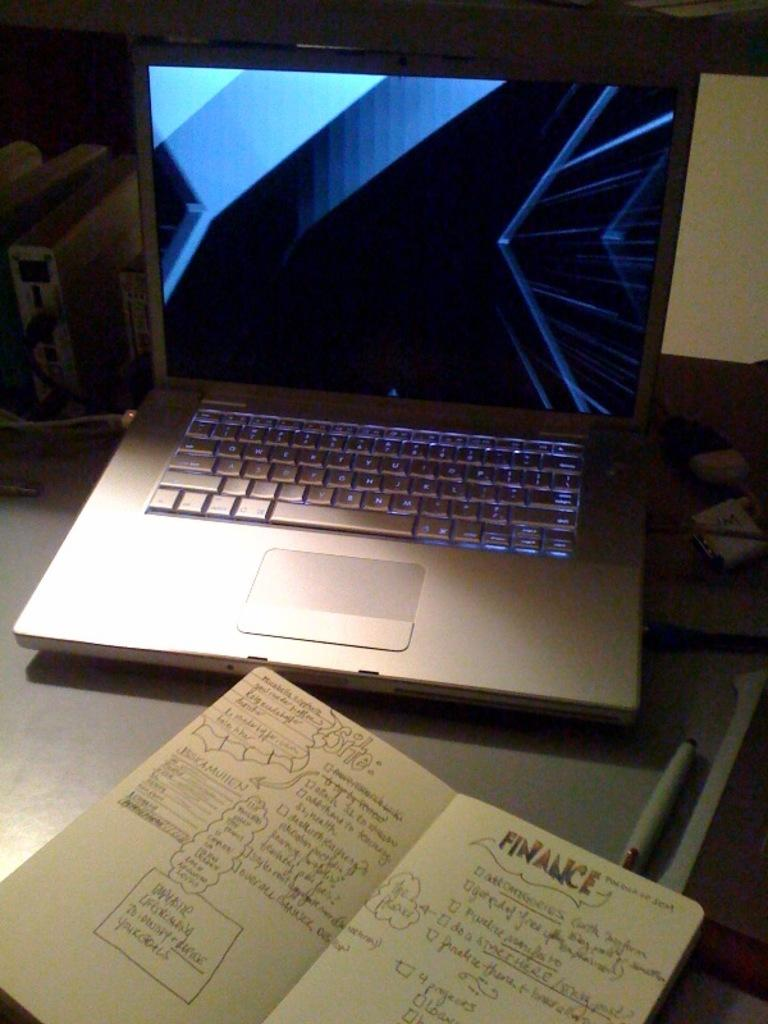<image>
Present a compact description of the photo's key features. An open laptop with an open notebook that reads finance on top of the right page. 